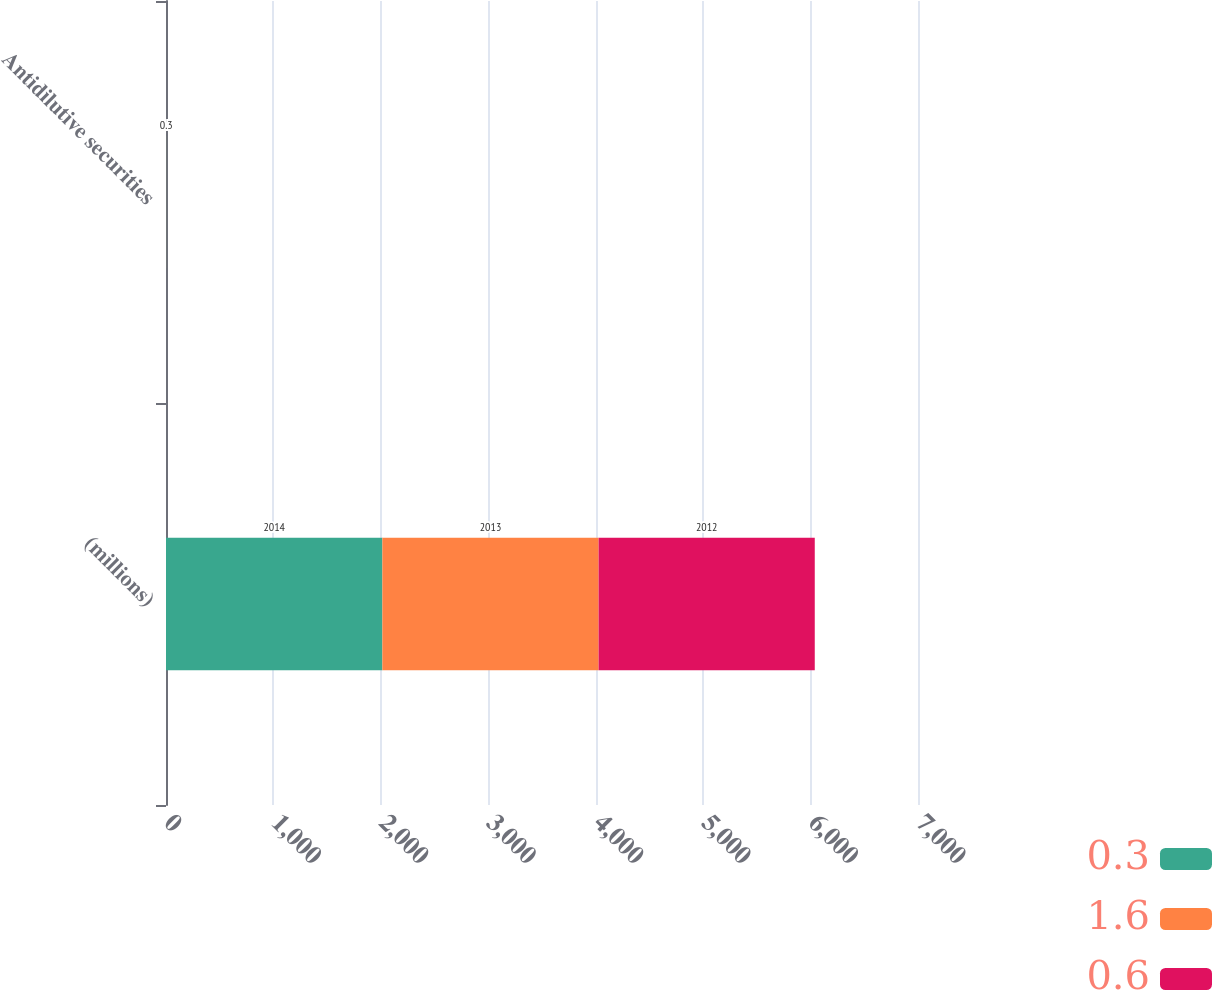Convert chart. <chart><loc_0><loc_0><loc_500><loc_500><stacked_bar_chart><ecel><fcel>(millions)<fcel>Antidilutive securities<nl><fcel>0.3<fcel>2014<fcel>1.6<nl><fcel>1.6<fcel>2013<fcel>0.6<nl><fcel>0.6<fcel>2012<fcel>0.3<nl></chart> 